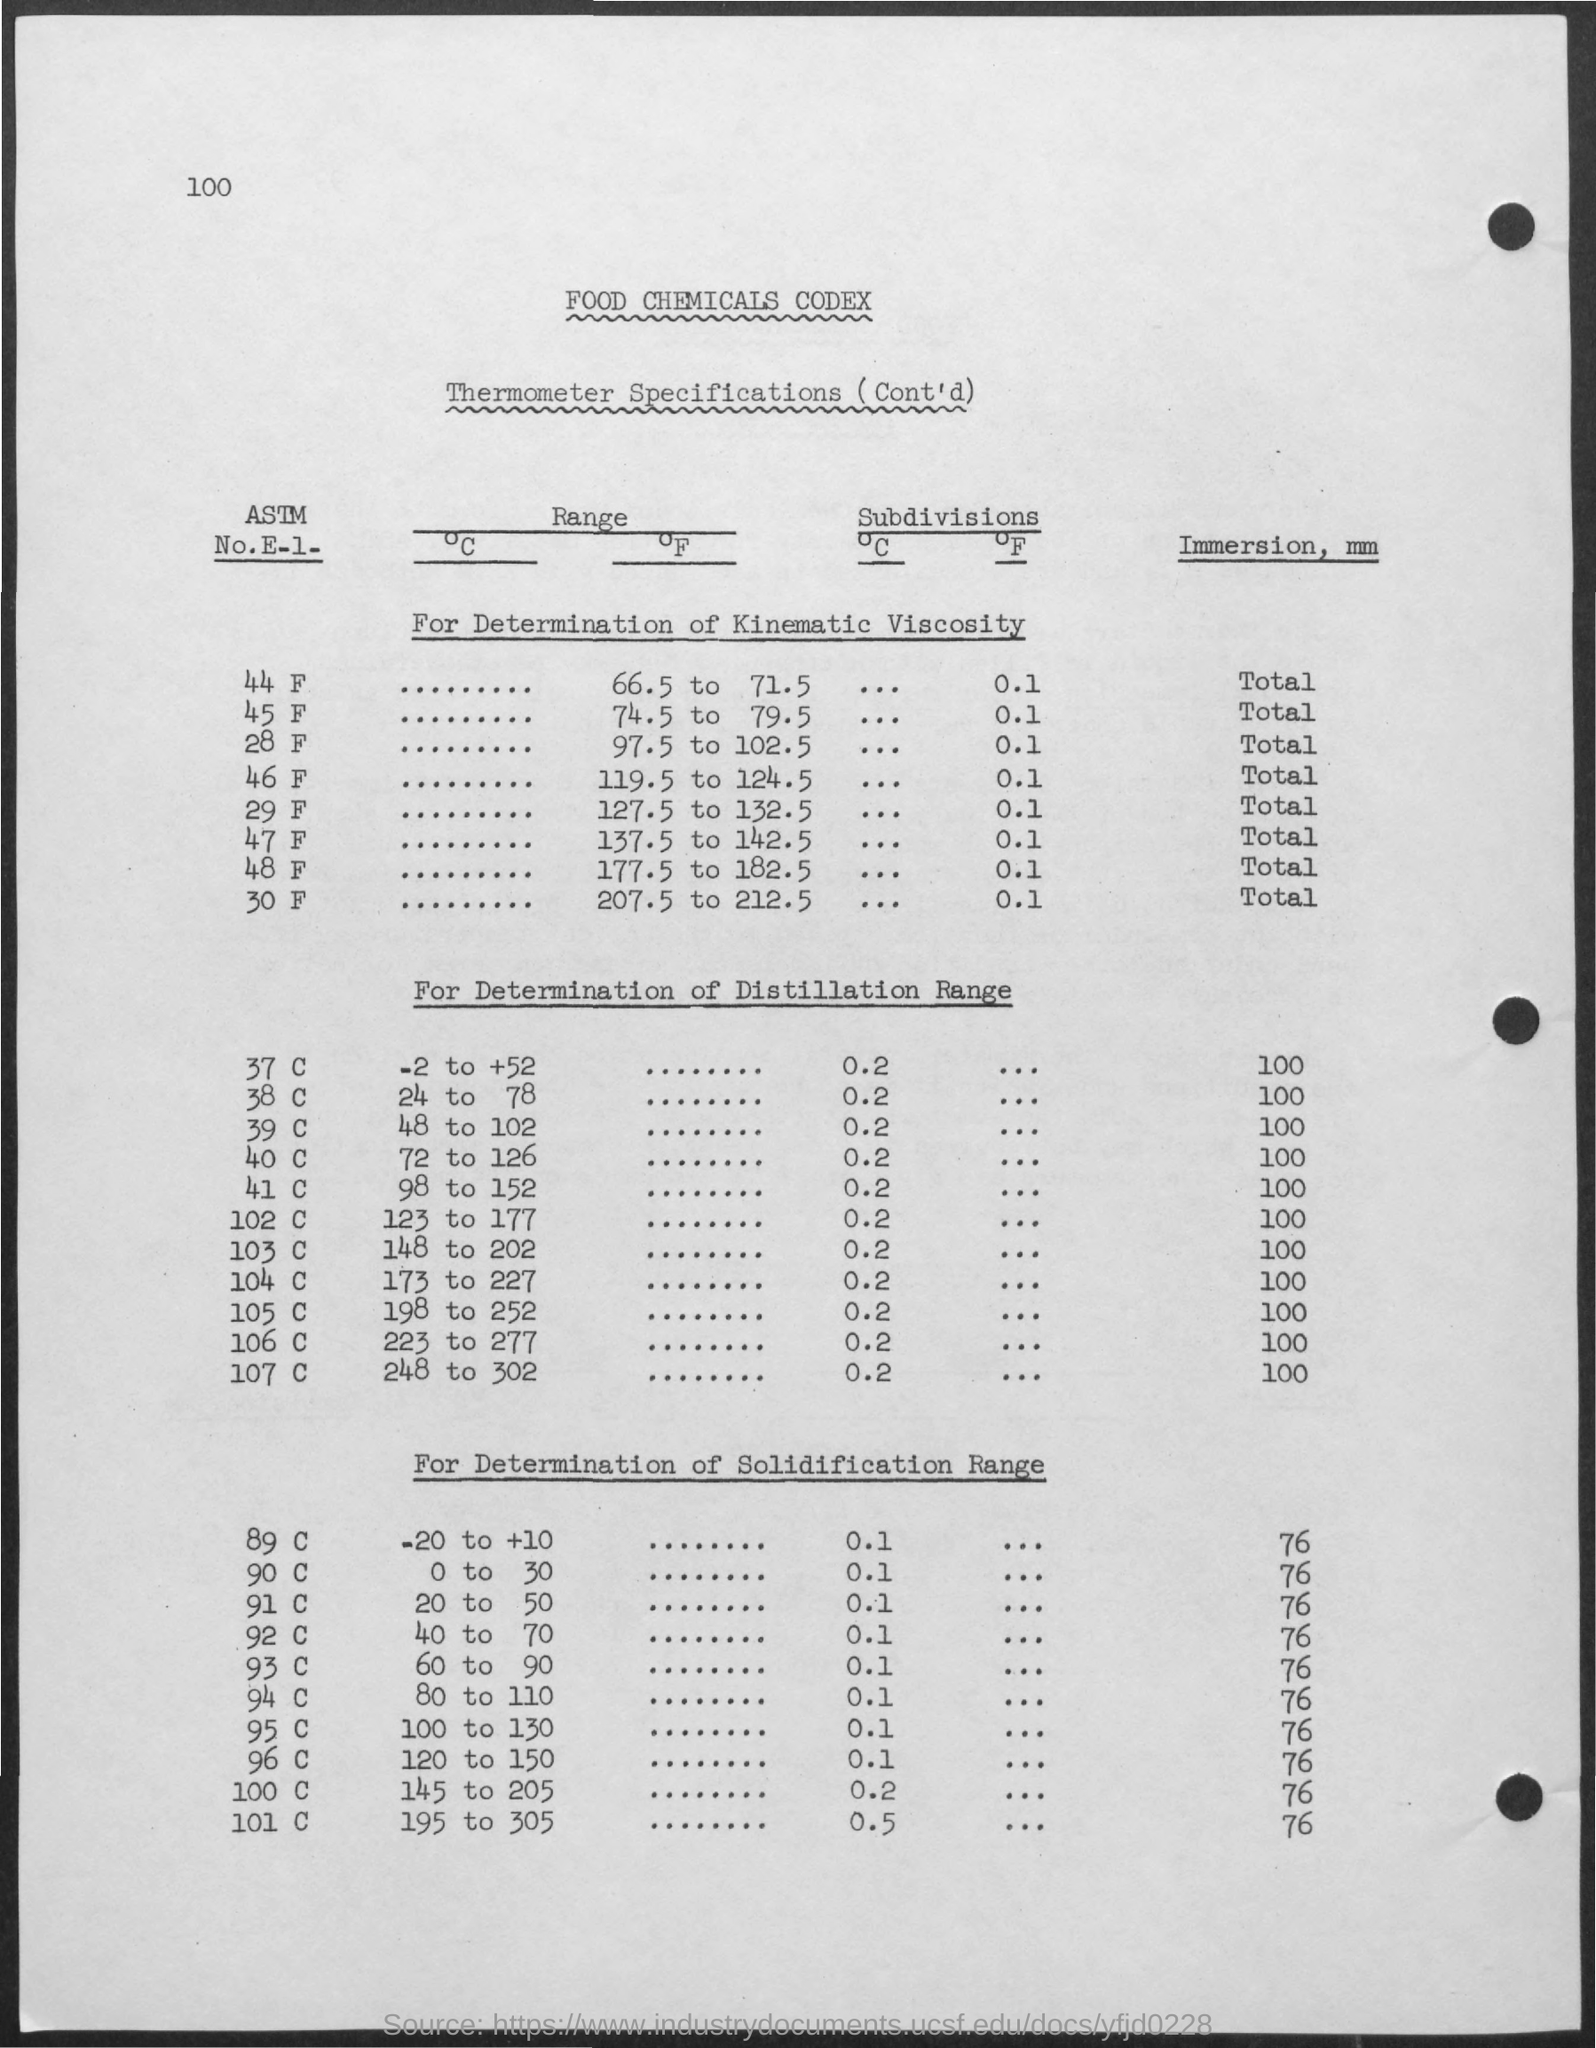Outline some significant characteristics in this image. The immersion of 37 Celsius degrees in millimeters is 100. The range for 37 degrees Celsius is -2 to +52 degrees Celsius. Immersion is typically measured in millimeters (mm). What is the subdivisions of 44 F? It is made up of units such as 0.1, 0.01, and 0.001, and so on. The range of 45 F is between 74.5 and 79.5 degrees Fahrenheit. 